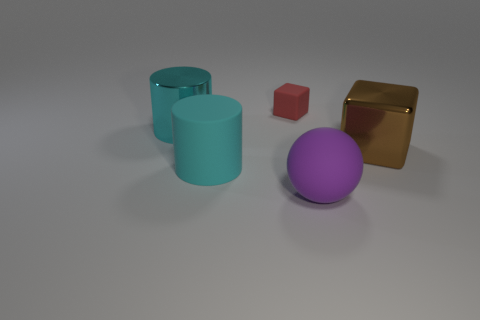Add 2 metal blocks. How many objects exist? 7 Add 1 large rubber things. How many large rubber things are left? 3 Add 5 cyan rubber things. How many cyan rubber things exist? 6 Subtract 1 red cubes. How many objects are left? 4 Subtract all blocks. How many objects are left? 3 Subtract 2 cubes. How many cubes are left? 0 Subtract all purple cubes. Subtract all brown balls. How many cubes are left? 2 Subtract all yellow cylinders. How many blue cubes are left? 0 Subtract all large rubber objects. Subtract all shiny cylinders. How many objects are left? 2 